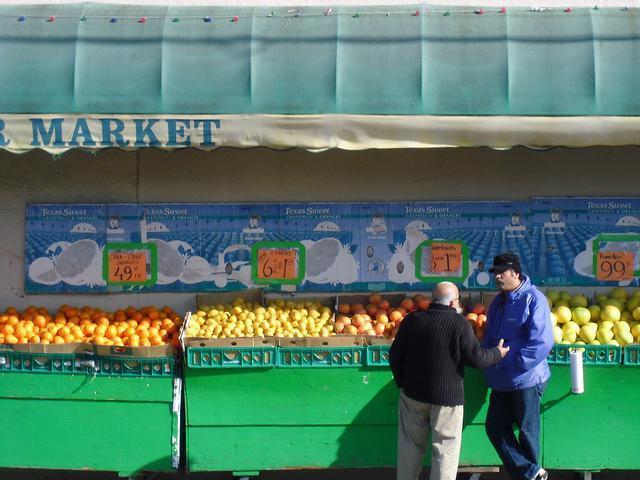How many people are in the photo?
Give a very brief answer. 2. How many oranges are visible?
Give a very brief answer. 3. How many apples are there?
Give a very brief answer. 3. 